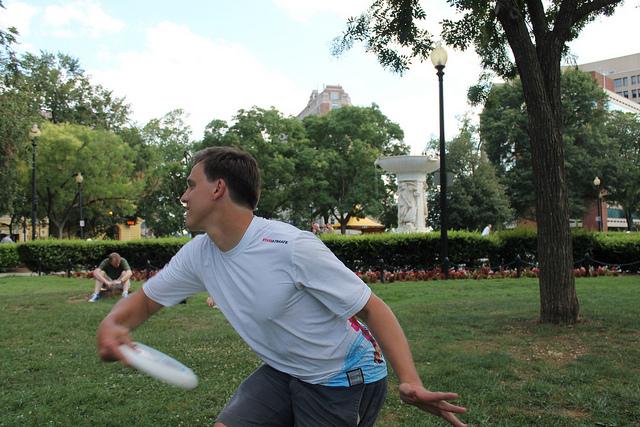Is the person male or female?
Answer briefly. Male. How many people are in the photo?
Short answer required. 2. Is there a man in the background?
Give a very brief answer. Yes. What is this person throwing?
Answer briefly. Frisbee. What color is the frisbee?
Write a very short answer. White. What color shirt is he wearing?
Give a very brief answer. White. What color is this guy wearing?
Answer briefly. White. What color are the men's shirts?
Quick response, please. White. Is he in an open field?
Be succinct. No. What color is the man's shirt?
Keep it brief. White. What's in his hand?
Short answer required. Frisbee. What is the frisbee?
Quick response, please. White. What is the color of the placemats?
Write a very short answer. White. Shouldn't he lose some weight?
Short answer required. No. Would this be a good locale for cattle to roam in?
Give a very brief answer. No. 